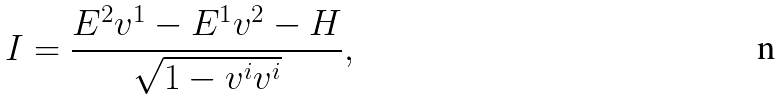<formula> <loc_0><loc_0><loc_500><loc_500>I = \frac { E ^ { 2 } v ^ { 1 } - E ^ { 1 } v ^ { 2 } - H } { \sqrt { 1 - v ^ { i } v ^ { i } } } ,</formula> 